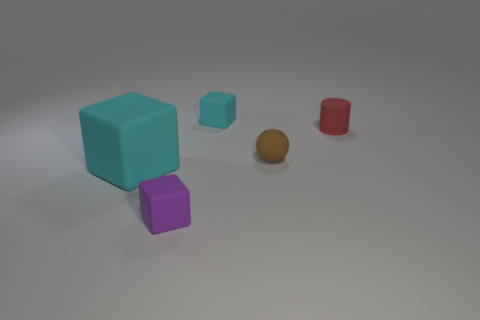Add 5 red objects. How many objects exist? 10 Subtract all balls. How many objects are left? 4 Add 4 small brown things. How many small brown things are left? 5 Add 5 brown objects. How many brown objects exist? 6 Subtract 1 purple blocks. How many objects are left? 4 Subtract all small cyan metallic cylinders. Subtract all small spheres. How many objects are left? 4 